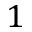Convert formula to latex. <formula><loc_0><loc_0><loc_500><loc_500>1</formula> 